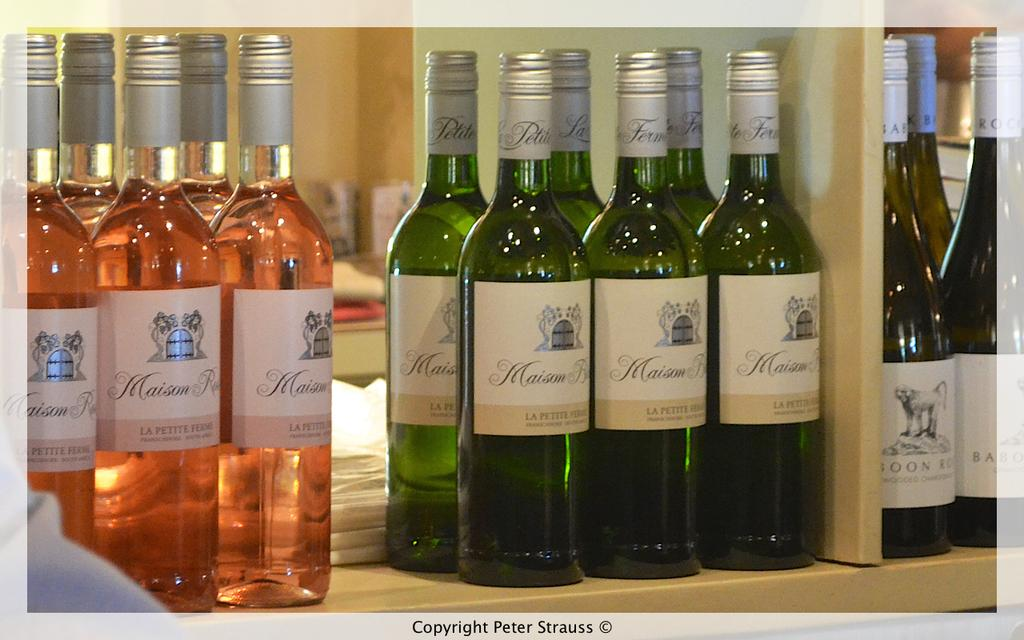<image>
Create a compact narrative representing the image presented. Wine displayed on a store shelf, several different varities including LA Petite Ferms. 